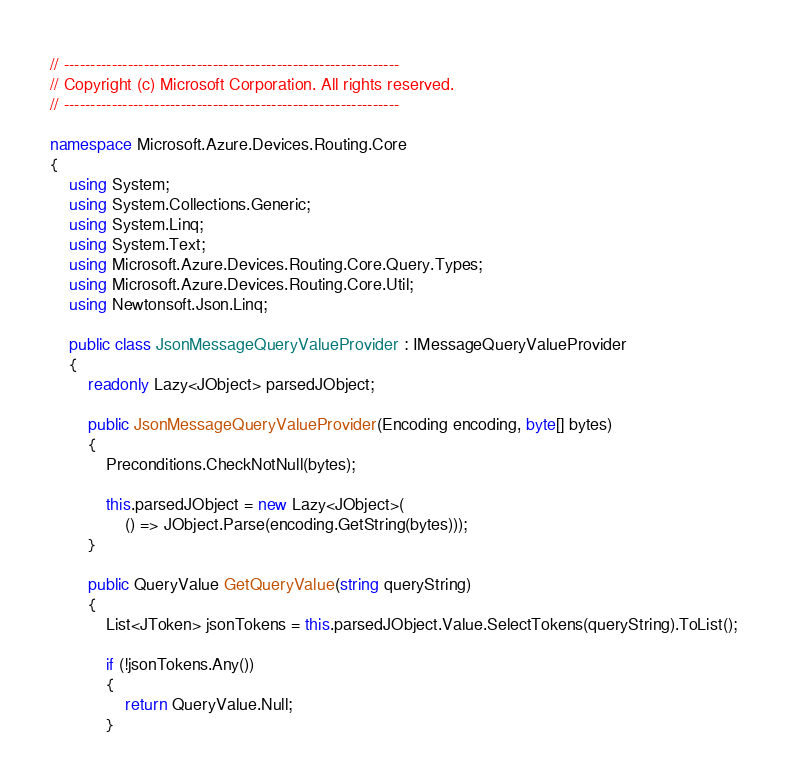<code> <loc_0><loc_0><loc_500><loc_500><_C#_>// ---------------------------------------------------------------
// Copyright (c) Microsoft Corporation. All rights reserved.
// ---------------------------------------------------------------

namespace Microsoft.Azure.Devices.Routing.Core
{
    using System;
    using System.Collections.Generic;
    using System.Linq;
    using System.Text;
    using Microsoft.Azure.Devices.Routing.Core.Query.Types;
    using Microsoft.Azure.Devices.Routing.Core.Util;
    using Newtonsoft.Json.Linq;

    public class JsonMessageQueryValueProvider : IMessageQueryValueProvider
    {
        readonly Lazy<JObject> parsedJObject;

        public JsonMessageQueryValueProvider(Encoding encoding, byte[] bytes)
        {
            Preconditions.CheckNotNull(bytes);

            this.parsedJObject = new Lazy<JObject>(
                () => JObject.Parse(encoding.GetString(bytes)));
        }

        public QueryValue GetQueryValue(string queryString)
        {
            List<JToken> jsonTokens = this.parsedJObject.Value.SelectTokens(queryString).ToList();

            if (!jsonTokens.Any())
            {
                return QueryValue.Null;
            }</code> 